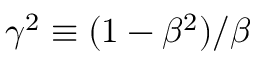Convert formula to latex. <formula><loc_0><loc_0><loc_500><loc_500>\gamma ^ { 2 } \equiv ( 1 - \beta ^ { 2 } ) / \beta</formula> 